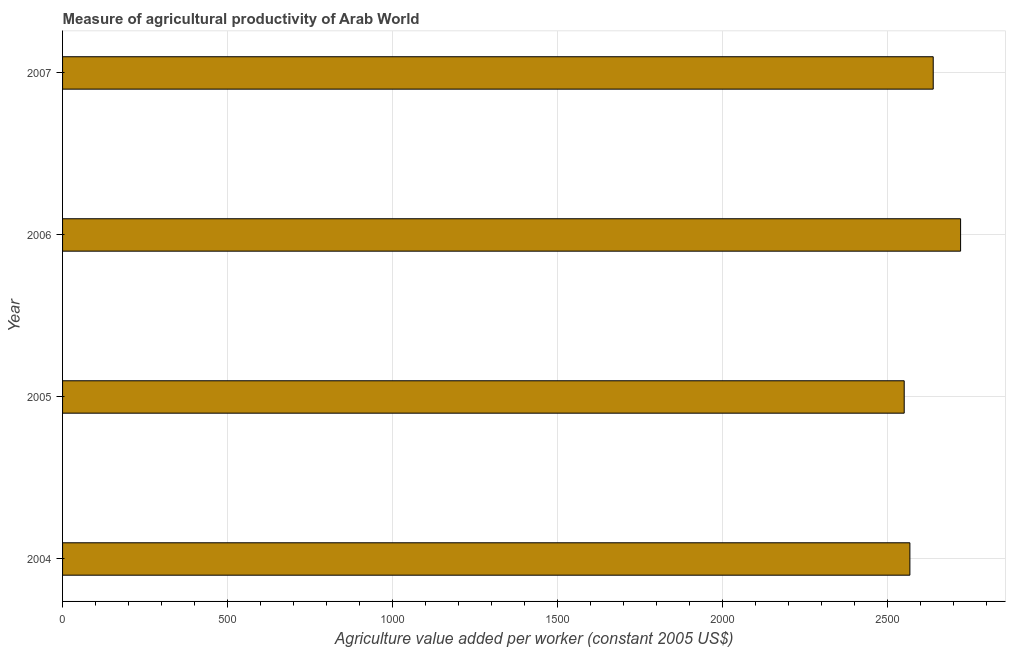Does the graph contain grids?
Give a very brief answer. Yes. What is the title of the graph?
Provide a short and direct response. Measure of agricultural productivity of Arab World. What is the label or title of the X-axis?
Offer a terse response. Agriculture value added per worker (constant 2005 US$). What is the label or title of the Y-axis?
Provide a succinct answer. Year. What is the agriculture value added per worker in 2007?
Your answer should be compact. 2639.36. Across all years, what is the maximum agriculture value added per worker?
Keep it short and to the point. 2722.33. Across all years, what is the minimum agriculture value added per worker?
Give a very brief answer. 2551.4. In which year was the agriculture value added per worker minimum?
Offer a very short reply. 2005. What is the sum of the agriculture value added per worker?
Provide a succinct answer. 1.05e+04. What is the difference between the agriculture value added per worker in 2006 and 2007?
Provide a short and direct response. 82.97. What is the average agriculture value added per worker per year?
Keep it short and to the point. 2620.43. What is the median agriculture value added per worker?
Ensure brevity in your answer.  2603.99. What is the ratio of the agriculture value added per worker in 2004 to that in 2006?
Your answer should be compact. 0.94. Is the agriculture value added per worker in 2005 less than that in 2006?
Provide a succinct answer. Yes. What is the difference between the highest and the second highest agriculture value added per worker?
Your answer should be very brief. 82.97. Is the sum of the agriculture value added per worker in 2004 and 2005 greater than the maximum agriculture value added per worker across all years?
Ensure brevity in your answer.  Yes. What is the difference between the highest and the lowest agriculture value added per worker?
Make the answer very short. 170.93. In how many years, is the agriculture value added per worker greater than the average agriculture value added per worker taken over all years?
Your answer should be very brief. 2. How many bars are there?
Provide a short and direct response. 4. How many years are there in the graph?
Keep it short and to the point. 4. What is the difference between two consecutive major ticks on the X-axis?
Offer a very short reply. 500. Are the values on the major ticks of X-axis written in scientific E-notation?
Keep it short and to the point. No. What is the Agriculture value added per worker (constant 2005 US$) in 2004?
Provide a short and direct response. 2568.62. What is the Agriculture value added per worker (constant 2005 US$) in 2005?
Your answer should be very brief. 2551.4. What is the Agriculture value added per worker (constant 2005 US$) of 2006?
Provide a succinct answer. 2722.33. What is the Agriculture value added per worker (constant 2005 US$) in 2007?
Offer a very short reply. 2639.36. What is the difference between the Agriculture value added per worker (constant 2005 US$) in 2004 and 2005?
Offer a terse response. 17.22. What is the difference between the Agriculture value added per worker (constant 2005 US$) in 2004 and 2006?
Offer a very short reply. -153.71. What is the difference between the Agriculture value added per worker (constant 2005 US$) in 2004 and 2007?
Give a very brief answer. -70.74. What is the difference between the Agriculture value added per worker (constant 2005 US$) in 2005 and 2006?
Your answer should be very brief. -170.93. What is the difference between the Agriculture value added per worker (constant 2005 US$) in 2005 and 2007?
Your response must be concise. -87.95. What is the difference between the Agriculture value added per worker (constant 2005 US$) in 2006 and 2007?
Provide a succinct answer. 82.97. What is the ratio of the Agriculture value added per worker (constant 2005 US$) in 2004 to that in 2006?
Your answer should be very brief. 0.94. What is the ratio of the Agriculture value added per worker (constant 2005 US$) in 2005 to that in 2006?
Your answer should be very brief. 0.94. What is the ratio of the Agriculture value added per worker (constant 2005 US$) in 2005 to that in 2007?
Provide a succinct answer. 0.97. What is the ratio of the Agriculture value added per worker (constant 2005 US$) in 2006 to that in 2007?
Ensure brevity in your answer.  1.03. 